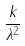Convert formula to latex. <formula><loc_0><loc_0><loc_500><loc_500>\frac { k } { \lambda ^ { 2 } }</formula> 